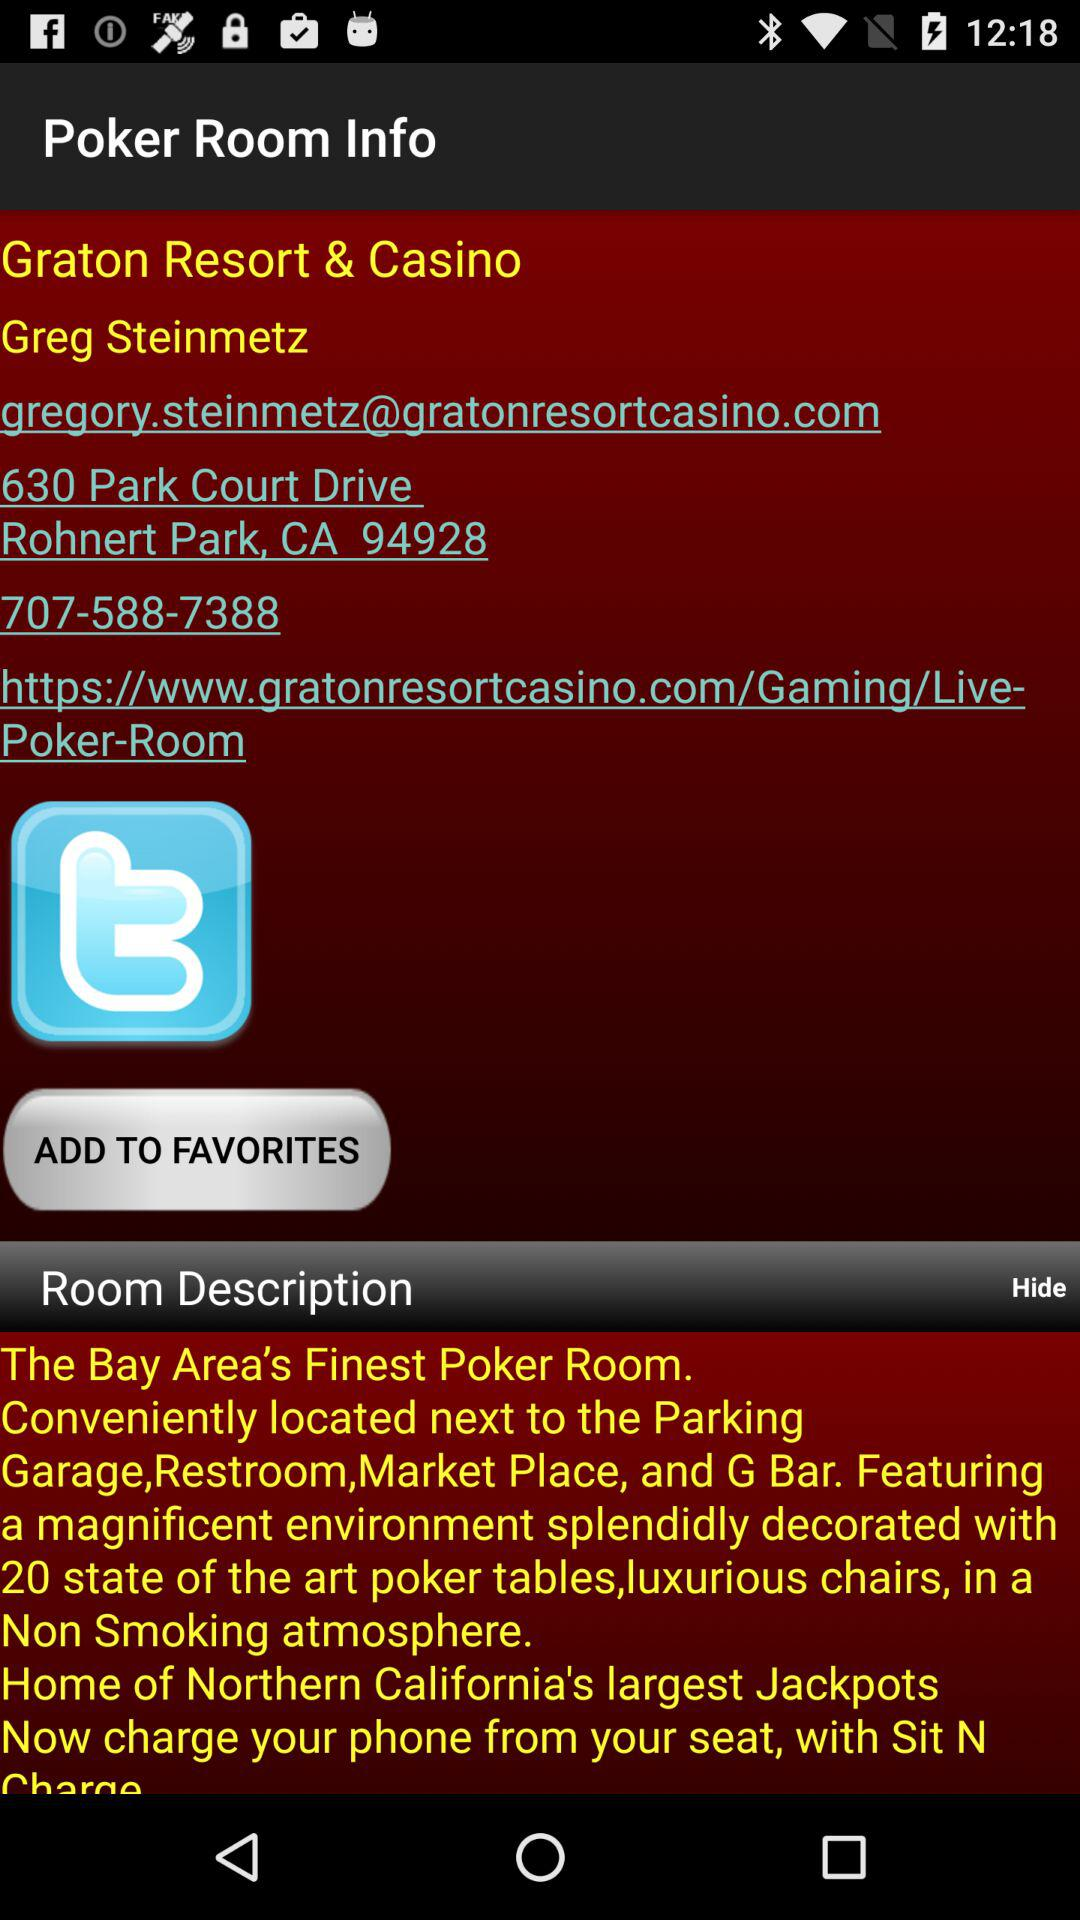How many poker tables are there in the poker room? There are 20 poker tables in the poker room. 